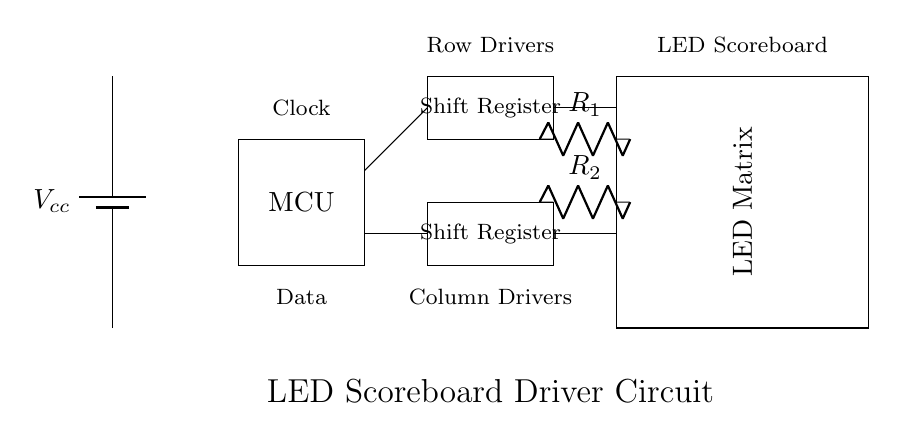What is the voltage supply in this circuit? The circuit uses a battery labeled as Vcc, and although the exact value is not specified in the diagram, it is typically assumed to be a standard voltage such as 5V or 12V used in LED circuits.
Answer: Vcc What do the rectangles represent in this circuit? The rectangles in the circuit diagram represent components: one for the microcontroller, one for the LED matrix, and two for the shift registers. Each rectangle is labeled accordingly.
Answer: Components How many shift registers are present in the circuit? There are two rectangles labeled as Shift Register, which indicates that there are two shift registers present in this circuit.
Answer: Two What is the purpose of the current-limiting resistors? The resistors labeled R1 and R2 connected to the LED matrix serve to limit the current flowing through the LEDs, preventing damage by ensuring they do not exceed their rated operating current.
Answer: Limit current Describe the data connections in this circuit. The data connections include lines from the microcontroller that connect to both shift registers. The top one connects to the top shift register and the bottom one to the bottom shift register, shown by the lines drawn.
Answer: Microcontroller to shift registers What drives the LED matrix? The LED matrix is driven by signals from the shift registers, which receive data from the microcontroller, controlling how the LEDs illuminate. The connection directed from the shift registers to the LED matrix indicates this.
Answer: Shift Registers 